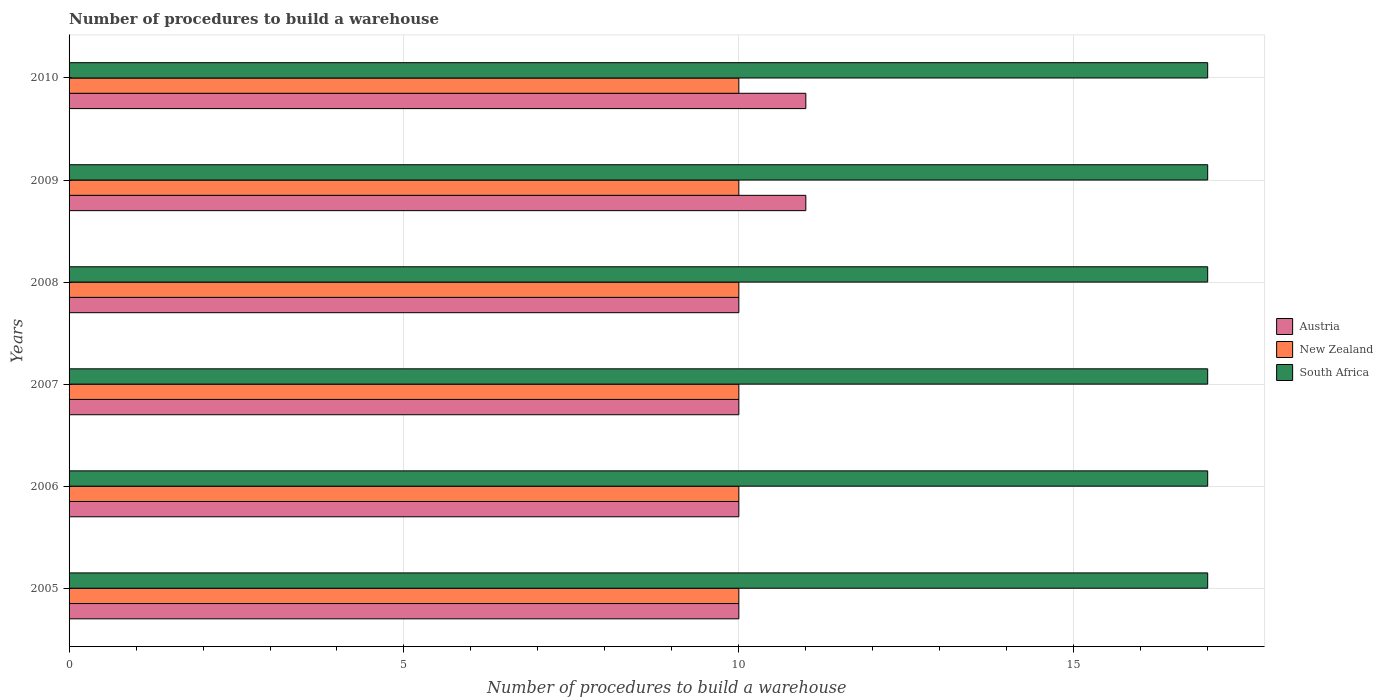How many different coloured bars are there?
Give a very brief answer. 3. Are the number of bars per tick equal to the number of legend labels?
Make the answer very short. Yes. Are the number of bars on each tick of the Y-axis equal?
Your answer should be very brief. Yes. How many bars are there on the 3rd tick from the top?
Give a very brief answer. 3. What is the number of procedures to build a warehouse in in Austria in 2009?
Provide a short and direct response. 11. Across all years, what is the maximum number of procedures to build a warehouse in in Austria?
Make the answer very short. 11. Across all years, what is the minimum number of procedures to build a warehouse in in Austria?
Give a very brief answer. 10. In which year was the number of procedures to build a warehouse in in Austria maximum?
Your answer should be very brief. 2009. What is the total number of procedures to build a warehouse in in Austria in the graph?
Make the answer very short. 62. What is the difference between the number of procedures to build a warehouse in in Austria in 2007 and that in 2010?
Your answer should be compact. -1. What is the difference between the number of procedures to build a warehouse in in South Africa in 2005 and the number of procedures to build a warehouse in in New Zealand in 2008?
Ensure brevity in your answer.  7. In the year 2005, what is the difference between the number of procedures to build a warehouse in in South Africa and number of procedures to build a warehouse in in Austria?
Your answer should be compact. 7. In how many years, is the number of procedures to build a warehouse in in New Zealand greater than 4 ?
Give a very brief answer. 6. What is the ratio of the number of procedures to build a warehouse in in South Africa in 2006 to that in 2009?
Ensure brevity in your answer.  1. Is the difference between the number of procedures to build a warehouse in in South Africa in 2008 and 2009 greater than the difference between the number of procedures to build a warehouse in in Austria in 2008 and 2009?
Make the answer very short. Yes. What is the difference between the highest and the second highest number of procedures to build a warehouse in in New Zealand?
Your answer should be very brief. 0. Is the sum of the number of procedures to build a warehouse in in New Zealand in 2006 and 2007 greater than the maximum number of procedures to build a warehouse in in Austria across all years?
Your answer should be very brief. Yes. What does the 1st bar from the top in 2006 represents?
Ensure brevity in your answer.  South Africa. Is it the case that in every year, the sum of the number of procedures to build a warehouse in in Austria and number of procedures to build a warehouse in in South Africa is greater than the number of procedures to build a warehouse in in New Zealand?
Provide a short and direct response. Yes. How many bars are there?
Give a very brief answer. 18. Are all the bars in the graph horizontal?
Provide a short and direct response. Yes. Where does the legend appear in the graph?
Your response must be concise. Center right. How many legend labels are there?
Ensure brevity in your answer.  3. How are the legend labels stacked?
Give a very brief answer. Vertical. What is the title of the graph?
Make the answer very short. Number of procedures to build a warehouse. Does "Turkmenistan" appear as one of the legend labels in the graph?
Provide a succinct answer. No. What is the label or title of the X-axis?
Give a very brief answer. Number of procedures to build a warehouse. What is the Number of procedures to build a warehouse of New Zealand in 2005?
Make the answer very short. 10. What is the Number of procedures to build a warehouse of South Africa in 2005?
Ensure brevity in your answer.  17. What is the Number of procedures to build a warehouse in Austria in 2006?
Offer a very short reply. 10. What is the Number of procedures to build a warehouse of New Zealand in 2006?
Give a very brief answer. 10. What is the Number of procedures to build a warehouse of Austria in 2007?
Ensure brevity in your answer.  10. What is the Number of procedures to build a warehouse in Austria in 2009?
Make the answer very short. 11. What is the Number of procedures to build a warehouse of New Zealand in 2009?
Offer a terse response. 10. What is the Number of procedures to build a warehouse of South Africa in 2009?
Offer a terse response. 17. What is the Number of procedures to build a warehouse of New Zealand in 2010?
Provide a succinct answer. 10. What is the Number of procedures to build a warehouse of South Africa in 2010?
Provide a succinct answer. 17. Across all years, what is the maximum Number of procedures to build a warehouse in South Africa?
Provide a short and direct response. 17. Across all years, what is the minimum Number of procedures to build a warehouse in New Zealand?
Provide a succinct answer. 10. What is the total Number of procedures to build a warehouse in Austria in the graph?
Ensure brevity in your answer.  62. What is the total Number of procedures to build a warehouse of South Africa in the graph?
Make the answer very short. 102. What is the difference between the Number of procedures to build a warehouse of South Africa in 2005 and that in 2006?
Ensure brevity in your answer.  0. What is the difference between the Number of procedures to build a warehouse in Austria in 2005 and that in 2007?
Make the answer very short. 0. What is the difference between the Number of procedures to build a warehouse of New Zealand in 2005 and that in 2007?
Give a very brief answer. 0. What is the difference between the Number of procedures to build a warehouse of Austria in 2005 and that in 2008?
Provide a succinct answer. 0. What is the difference between the Number of procedures to build a warehouse in New Zealand in 2005 and that in 2008?
Your answer should be very brief. 0. What is the difference between the Number of procedures to build a warehouse in Austria in 2005 and that in 2009?
Your response must be concise. -1. What is the difference between the Number of procedures to build a warehouse in Austria in 2006 and that in 2007?
Offer a very short reply. 0. What is the difference between the Number of procedures to build a warehouse in New Zealand in 2006 and that in 2007?
Offer a very short reply. 0. What is the difference between the Number of procedures to build a warehouse of South Africa in 2006 and that in 2007?
Your response must be concise. 0. What is the difference between the Number of procedures to build a warehouse of Austria in 2006 and that in 2009?
Make the answer very short. -1. What is the difference between the Number of procedures to build a warehouse in New Zealand in 2006 and that in 2009?
Keep it short and to the point. 0. What is the difference between the Number of procedures to build a warehouse of Austria in 2006 and that in 2010?
Your answer should be compact. -1. What is the difference between the Number of procedures to build a warehouse in New Zealand in 2006 and that in 2010?
Your answer should be compact. 0. What is the difference between the Number of procedures to build a warehouse in South Africa in 2006 and that in 2010?
Your answer should be compact. 0. What is the difference between the Number of procedures to build a warehouse of South Africa in 2007 and that in 2008?
Provide a short and direct response. 0. What is the difference between the Number of procedures to build a warehouse of New Zealand in 2007 and that in 2009?
Offer a terse response. 0. What is the difference between the Number of procedures to build a warehouse of South Africa in 2007 and that in 2009?
Offer a terse response. 0. What is the difference between the Number of procedures to build a warehouse of South Africa in 2008 and that in 2009?
Keep it short and to the point. 0. What is the difference between the Number of procedures to build a warehouse in South Africa in 2008 and that in 2010?
Your answer should be very brief. 0. What is the difference between the Number of procedures to build a warehouse in New Zealand in 2009 and that in 2010?
Offer a very short reply. 0. What is the difference between the Number of procedures to build a warehouse in Austria in 2005 and the Number of procedures to build a warehouse in New Zealand in 2006?
Offer a terse response. 0. What is the difference between the Number of procedures to build a warehouse of New Zealand in 2005 and the Number of procedures to build a warehouse of South Africa in 2007?
Give a very brief answer. -7. What is the difference between the Number of procedures to build a warehouse in Austria in 2005 and the Number of procedures to build a warehouse in New Zealand in 2008?
Your answer should be compact. 0. What is the difference between the Number of procedures to build a warehouse of New Zealand in 2005 and the Number of procedures to build a warehouse of South Africa in 2008?
Offer a terse response. -7. What is the difference between the Number of procedures to build a warehouse of Austria in 2005 and the Number of procedures to build a warehouse of New Zealand in 2009?
Ensure brevity in your answer.  0. What is the difference between the Number of procedures to build a warehouse of New Zealand in 2005 and the Number of procedures to build a warehouse of South Africa in 2009?
Ensure brevity in your answer.  -7. What is the difference between the Number of procedures to build a warehouse in Austria in 2005 and the Number of procedures to build a warehouse in New Zealand in 2010?
Ensure brevity in your answer.  0. What is the difference between the Number of procedures to build a warehouse of Austria in 2006 and the Number of procedures to build a warehouse of South Africa in 2007?
Your answer should be very brief. -7. What is the difference between the Number of procedures to build a warehouse of Austria in 2006 and the Number of procedures to build a warehouse of New Zealand in 2009?
Your answer should be compact. 0. What is the difference between the Number of procedures to build a warehouse of Austria in 2006 and the Number of procedures to build a warehouse of South Africa in 2009?
Make the answer very short. -7. What is the difference between the Number of procedures to build a warehouse of New Zealand in 2006 and the Number of procedures to build a warehouse of South Africa in 2010?
Give a very brief answer. -7. What is the difference between the Number of procedures to build a warehouse in Austria in 2007 and the Number of procedures to build a warehouse in New Zealand in 2008?
Ensure brevity in your answer.  0. What is the difference between the Number of procedures to build a warehouse of New Zealand in 2007 and the Number of procedures to build a warehouse of South Africa in 2008?
Offer a very short reply. -7. What is the difference between the Number of procedures to build a warehouse of Austria in 2007 and the Number of procedures to build a warehouse of New Zealand in 2009?
Provide a short and direct response. 0. What is the difference between the Number of procedures to build a warehouse in Austria in 2007 and the Number of procedures to build a warehouse in South Africa in 2009?
Offer a very short reply. -7. What is the difference between the Number of procedures to build a warehouse of Austria in 2007 and the Number of procedures to build a warehouse of New Zealand in 2010?
Provide a succinct answer. 0. What is the difference between the Number of procedures to build a warehouse in Austria in 2007 and the Number of procedures to build a warehouse in South Africa in 2010?
Your response must be concise. -7. What is the difference between the Number of procedures to build a warehouse in Austria in 2008 and the Number of procedures to build a warehouse in New Zealand in 2009?
Your response must be concise. 0. What is the difference between the Number of procedures to build a warehouse of New Zealand in 2008 and the Number of procedures to build a warehouse of South Africa in 2010?
Provide a succinct answer. -7. What is the average Number of procedures to build a warehouse of Austria per year?
Your answer should be compact. 10.33. What is the average Number of procedures to build a warehouse in New Zealand per year?
Provide a short and direct response. 10. In the year 2006, what is the difference between the Number of procedures to build a warehouse in Austria and Number of procedures to build a warehouse in South Africa?
Keep it short and to the point. -7. In the year 2006, what is the difference between the Number of procedures to build a warehouse of New Zealand and Number of procedures to build a warehouse of South Africa?
Your answer should be compact. -7. In the year 2007, what is the difference between the Number of procedures to build a warehouse in Austria and Number of procedures to build a warehouse in South Africa?
Your answer should be compact. -7. In the year 2008, what is the difference between the Number of procedures to build a warehouse in Austria and Number of procedures to build a warehouse in New Zealand?
Keep it short and to the point. 0. In the year 2008, what is the difference between the Number of procedures to build a warehouse of Austria and Number of procedures to build a warehouse of South Africa?
Your response must be concise. -7. In the year 2009, what is the difference between the Number of procedures to build a warehouse in New Zealand and Number of procedures to build a warehouse in South Africa?
Offer a very short reply. -7. In the year 2010, what is the difference between the Number of procedures to build a warehouse in Austria and Number of procedures to build a warehouse in New Zealand?
Keep it short and to the point. 1. In the year 2010, what is the difference between the Number of procedures to build a warehouse in Austria and Number of procedures to build a warehouse in South Africa?
Make the answer very short. -6. In the year 2010, what is the difference between the Number of procedures to build a warehouse in New Zealand and Number of procedures to build a warehouse in South Africa?
Your answer should be compact. -7. What is the ratio of the Number of procedures to build a warehouse of Austria in 2005 to that in 2006?
Your response must be concise. 1. What is the ratio of the Number of procedures to build a warehouse of Austria in 2005 to that in 2007?
Provide a succinct answer. 1. What is the ratio of the Number of procedures to build a warehouse in New Zealand in 2005 to that in 2007?
Provide a succinct answer. 1. What is the ratio of the Number of procedures to build a warehouse in South Africa in 2005 to that in 2007?
Your response must be concise. 1. What is the ratio of the Number of procedures to build a warehouse in Austria in 2005 to that in 2008?
Keep it short and to the point. 1. What is the ratio of the Number of procedures to build a warehouse in New Zealand in 2005 to that in 2008?
Offer a terse response. 1. What is the ratio of the Number of procedures to build a warehouse of Austria in 2005 to that in 2009?
Give a very brief answer. 0.91. What is the ratio of the Number of procedures to build a warehouse in New Zealand in 2005 to that in 2010?
Offer a terse response. 1. What is the ratio of the Number of procedures to build a warehouse of South Africa in 2005 to that in 2010?
Give a very brief answer. 1. What is the ratio of the Number of procedures to build a warehouse in New Zealand in 2006 to that in 2007?
Keep it short and to the point. 1. What is the ratio of the Number of procedures to build a warehouse in New Zealand in 2006 to that in 2008?
Your answer should be very brief. 1. What is the ratio of the Number of procedures to build a warehouse of South Africa in 2006 to that in 2008?
Give a very brief answer. 1. What is the ratio of the Number of procedures to build a warehouse in Austria in 2006 to that in 2009?
Give a very brief answer. 0.91. What is the ratio of the Number of procedures to build a warehouse in South Africa in 2006 to that in 2009?
Your answer should be very brief. 1. What is the ratio of the Number of procedures to build a warehouse of Austria in 2006 to that in 2010?
Your answer should be very brief. 0.91. What is the ratio of the Number of procedures to build a warehouse of South Africa in 2007 to that in 2010?
Provide a short and direct response. 1. What is the ratio of the Number of procedures to build a warehouse in Austria in 2008 to that in 2009?
Provide a succinct answer. 0.91. What is the ratio of the Number of procedures to build a warehouse of New Zealand in 2008 to that in 2009?
Ensure brevity in your answer.  1. What is the ratio of the Number of procedures to build a warehouse of South Africa in 2008 to that in 2009?
Your answer should be compact. 1. What is the ratio of the Number of procedures to build a warehouse of Austria in 2008 to that in 2010?
Keep it short and to the point. 0.91. What is the ratio of the Number of procedures to build a warehouse in New Zealand in 2008 to that in 2010?
Make the answer very short. 1. What is the ratio of the Number of procedures to build a warehouse of Austria in 2009 to that in 2010?
Provide a succinct answer. 1. What is the difference between the highest and the second highest Number of procedures to build a warehouse of South Africa?
Give a very brief answer. 0. What is the difference between the highest and the lowest Number of procedures to build a warehouse in Austria?
Offer a very short reply. 1. What is the difference between the highest and the lowest Number of procedures to build a warehouse of South Africa?
Make the answer very short. 0. 